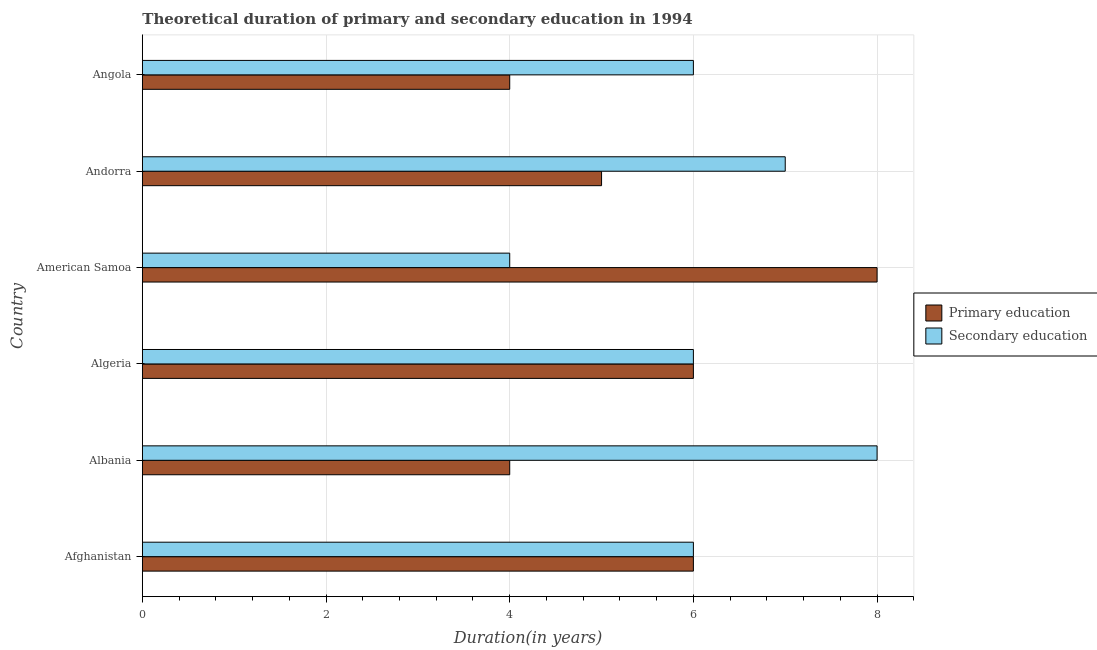How many different coloured bars are there?
Provide a succinct answer. 2. What is the label of the 6th group of bars from the top?
Provide a short and direct response. Afghanistan. What is the duration of secondary education in Andorra?
Your answer should be compact. 7. Across all countries, what is the maximum duration of secondary education?
Offer a terse response. 8. Across all countries, what is the minimum duration of secondary education?
Your answer should be compact. 4. In which country was the duration of primary education maximum?
Your answer should be very brief. American Samoa. In which country was the duration of secondary education minimum?
Make the answer very short. American Samoa. What is the total duration of primary education in the graph?
Give a very brief answer. 33. What is the difference between the duration of primary education in Albania and that in Andorra?
Keep it short and to the point. -1. What is the difference between the duration of secondary education in Andorra and the duration of primary education in Afghanistan?
Provide a succinct answer. 1. What is the average duration of secondary education per country?
Keep it short and to the point. 6.17. What is the ratio of the duration of primary education in Andorra to that in Angola?
Your answer should be compact. 1.25. Is the difference between the duration of primary education in Albania and Angola greater than the difference between the duration of secondary education in Albania and Angola?
Your answer should be compact. No. What is the difference between the highest and the lowest duration of secondary education?
Your answer should be compact. 4. What does the 1st bar from the top in Albania represents?
Give a very brief answer. Secondary education. What does the 1st bar from the bottom in Afghanistan represents?
Offer a very short reply. Primary education. How many bars are there?
Your response must be concise. 12. Are all the bars in the graph horizontal?
Your response must be concise. Yes. How many countries are there in the graph?
Provide a succinct answer. 6. How many legend labels are there?
Offer a terse response. 2. How are the legend labels stacked?
Give a very brief answer. Vertical. What is the title of the graph?
Offer a terse response. Theoretical duration of primary and secondary education in 1994. What is the label or title of the X-axis?
Ensure brevity in your answer.  Duration(in years). What is the label or title of the Y-axis?
Offer a very short reply. Country. What is the Duration(in years) in Secondary education in Afghanistan?
Provide a short and direct response. 6. What is the Duration(in years) of Primary education in Albania?
Make the answer very short. 4. What is the Duration(in years) in Secondary education in Albania?
Ensure brevity in your answer.  8. What is the Duration(in years) of Primary education in Algeria?
Offer a terse response. 6. What is the Duration(in years) in Primary education in Andorra?
Keep it short and to the point. 5. What is the Duration(in years) in Secondary education in Andorra?
Ensure brevity in your answer.  7. Across all countries, what is the maximum Duration(in years) of Primary education?
Make the answer very short. 8. Across all countries, what is the maximum Duration(in years) of Secondary education?
Make the answer very short. 8. What is the total Duration(in years) of Primary education in the graph?
Offer a very short reply. 33. What is the difference between the Duration(in years) of Primary education in Afghanistan and that in Albania?
Provide a short and direct response. 2. What is the difference between the Duration(in years) of Secondary education in Afghanistan and that in Albania?
Offer a very short reply. -2. What is the difference between the Duration(in years) of Primary education in Afghanistan and that in American Samoa?
Give a very brief answer. -2. What is the difference between the Duration(in years) in Primary education in Afghanistan and that in Andorra?
Keep it short and to the point. 1. What is the difference between the Duration(in years) in Secondary education in Afghanistan and that in Angola?
Offer a terse response. 0. What is the difference between the Duration(in years) in Primary education in Albania and that in Algeria?
Provide a short and direct response. -2. What is the difference between the Duration(in years) in Secondary education in Albania and that in Algeria?
Keep it short and to the point. 2. What is the difference between the Duration(in years) of Primary education in Albania and that in American Samoa?
Offer a terse response. -4. What is the difference between the Duration(in years) of Secondary education in Albania and that in American Samoa?
Your response must be concise. 4. What is the difference between the Duration(in years) in Secondary education in Albania and that in Angola?
Offer a very short reply. 2. What is the difference between the Duration(in years) of Secondary education in Algeria and that in Angola?
Make the answer very short. 0. What is the difference between the Duration(in years) in Primary education in American Samoa and that in Andorra?
Make the answer very short. 3. What is the difference between the Duration(in years) of Secondary education in American Samoa and that in Andorra?
Make the answer very short. -3. What is the difference between the Duration(in years) of Primary education in Andorra and that in Angola?
Your response must be concise. 1. What is the difference between the Duration(in years) of Primary education in Afghanistan and the Duration(in years) of Secondary education in Algeria?
Provide a succinct answer. 0. What is the difference between the Duration(in years) in Primary education in Afghanistan and the Duration(in years) in Secondary education in American Samoa?
Offer a very short reply. 2. What is the difference between the Duration(in years) in Primary education in Albania and the Duration(in years) in Secondary education in Algeria?
Your answer should be compact. -2. What is the difference between the Duration(in years) in Primary education in Albania and the Duration(in years) in Secondary education in Andorra?
Ensure brevity in your answer.  -3. What is the difference between the Duration(in years) of Primary education in Algeria and the Duration(in years) of Secondary education in Angola?
Your answer should be very brief. 0. What is the difference between the Duration(in years) in Primary education in American Samoa and the Duration(in years) in Secondary education in Andorra?
Offer a terse response. 1. What is the average Duration(in years) in Primary education per country?
Provide a succinct answer. 5.5. What is the average Duration(in years) of Secondary education per country?
Your answer should be compact. 6.17. What is the difference between the Duration(in years) of Primary education and Duration(in years) of Secondary education in Afghanistan?
Offer a terse response. 0. What is the difference between the Duration(in years) in Primary education and Duration(in years) in Secondary education in Albania?
Give a very brief answer. -4. What is the difference between the Duration(in years) in Primary education and Duration(in years) in Secondary education in American Samoa?
Your answer should be very brief. 4. What is the difference between the Duration(in years) of Primary education and Duration(in years) of Secondary education in Angola?
Your answer should be very brief. -2. What is the ratio of the Duration(in years) of Secondary education in Afghanistan to that in Albania?
Ensure brevity in your answer.  0.75. What is the ratio of the Duration(in years) of Primary education in Afghanistan to that in Algeria?
Your answer should be very brief. 1. What is the ratio of the Duration(in years) in Primary education in Afghanistan to that in Andorra?
Your answer should be very brief. 1.2. What is the ratio of the Duration(in years) of Secondary education in Afghanistan to that in Andorra?
Give a very brief answer. 0.86. What is the ratio of the Duration(in years) in Primary education in Afghanistan to that in Angola?
Provide a short and direct response. 1.5. What is the ratio of the Duration(in years) in Secondary education in Afghanistan to that in Angola?
Your answer should be very brief. 1. What is the ratio of the Duration(in years) in Primary education in Albania to that in American Samoa?
Your answer should be very brief. 0.5. What is the ratio of the Duration(in years) in Primary education in Albania to that in Andorra?
Your response must be concise. 0.8. What is the ratio of the Duration(in years) in Primary education in Albania to that in Angola?
Your response must be concise. 1. What is the ratio of the Duration(in years) of Primary education in Algeria to that in Angola?
Offer a terse response. 1.5. What is the ratio of the Duration(in years) of Secondary education in Algeria to that in Angola?
Ensure brevity in your answer.  1. What is the ratio of the Duration(in years) in Secondary education in American Samoa to that in Andorra?
Your answer should be very brief. 0.57. What is the ratio of the Duration(in years) of Secondary education in American Samoa to that in Angola?
Provide a short and direct response. 0.67. What is the difference between the highest and the second highest Duration(in years) of Primary education?
Offer a terse response. 2. What is the difference between the highest and the second highest Duration(in years) in Secondary education?
Ensure brevity in your answer.  1. 